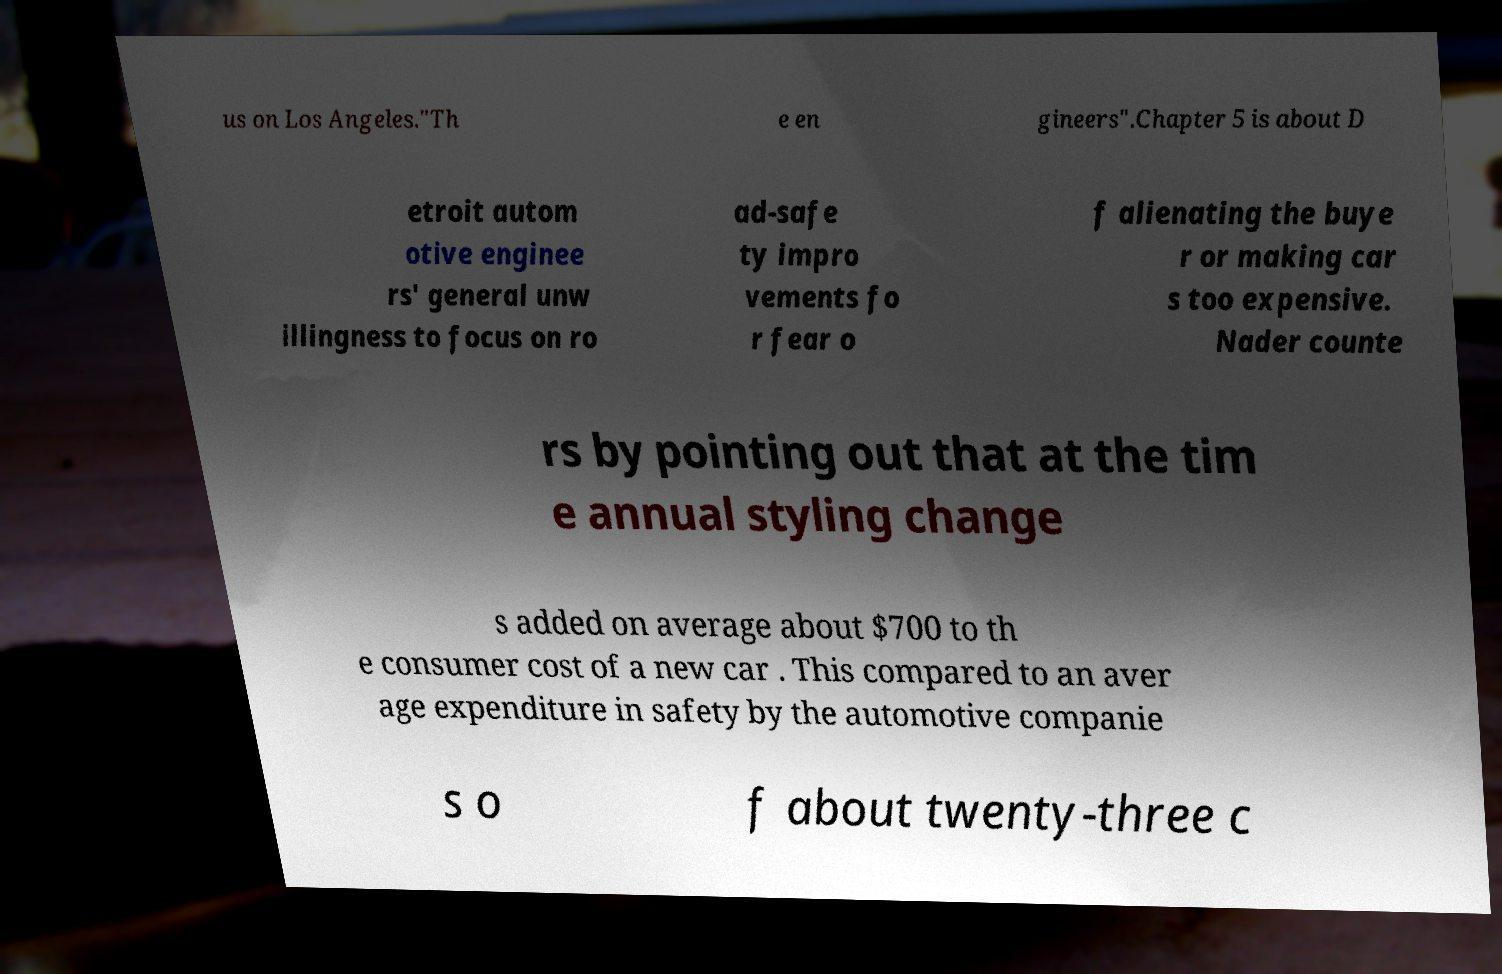Could you extract and type out the text from this image? us on Los Angeles."Th e en gineers".Chapter 5 is about D etroit autom otive enginee rs' general unw illingness to focus on ro ad-safe ty impro vements fo r fear o f alienating the buye r or making car s too expensive. Nader counte rs by pointing out that at the tim e annual styling change s added on average about $700 to th e consumer cost of a new car . This compared to an aver age expenditure in safety by the automotive companie s o f about twenty-three c 